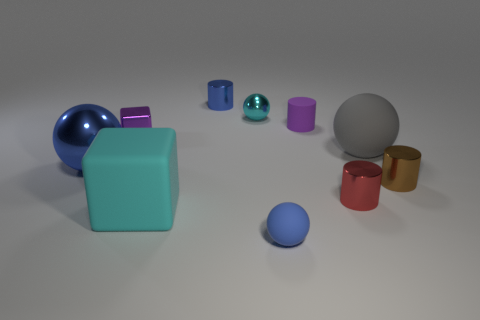How many metallic things are to the right of the blue matte ball?
Give a very brief answer. 2. What is the material of the blue thing that is behind the tiny red cylinder and right of the cyan matte cube?
Offer a terse response. Metal. How many large things are either purple metallic spheres or cyan rubber blocks?
Provide a succinct answer. 1. What size is the purple metal block?
Give a very brief answer. Small. What is the shape of the tiny purple metal thing?
Your answer should be very brief. Cube. Are there fewer metallic things that are behind the tiny purple metallic object than rubber things?
Offer a terse response. Yes. Do the sphere to the left of the large cyan rubber object and the small matte sphere have the same color?
Ensure brevity in your answer.  Yes. What number of rubber things are either small brown cylinders or tiny gray blocks?
Your response must be concise. 0. There is a large block that is made of the same material as the small purple cylinder; what is its color?
Your answer should be compact. Cyan. What number of spheres are either large matte objects or blue shiny objects?
Offer a terse response. 2. 